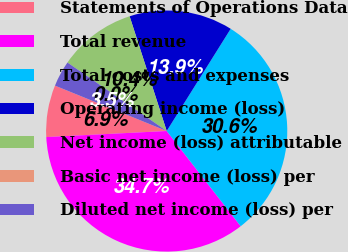Convert chart to OTSL. <chart><loc_0><loc_0><loc_500><loc_500><pie_chart><fcel>Statements of Operations Data<fcel>Total revenue<fcel>Total costs and expenses<fcel>Operating income (loss)<fcel>Net income (loss) attributable<fcel>Basic net income (loss) per<fcel>Diluted net income (loss) per<nl><fcel>6.94%<fcel>34.71%<fcel>30.58%<fcel>13.88%<fcel>10.41%<fcel>0.0%<fcel>3.47%<nl></chart> 